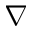Convert formula to latex. <formula><loc_0><loc_0><loc_500><loc_500>\nabla</formula> 